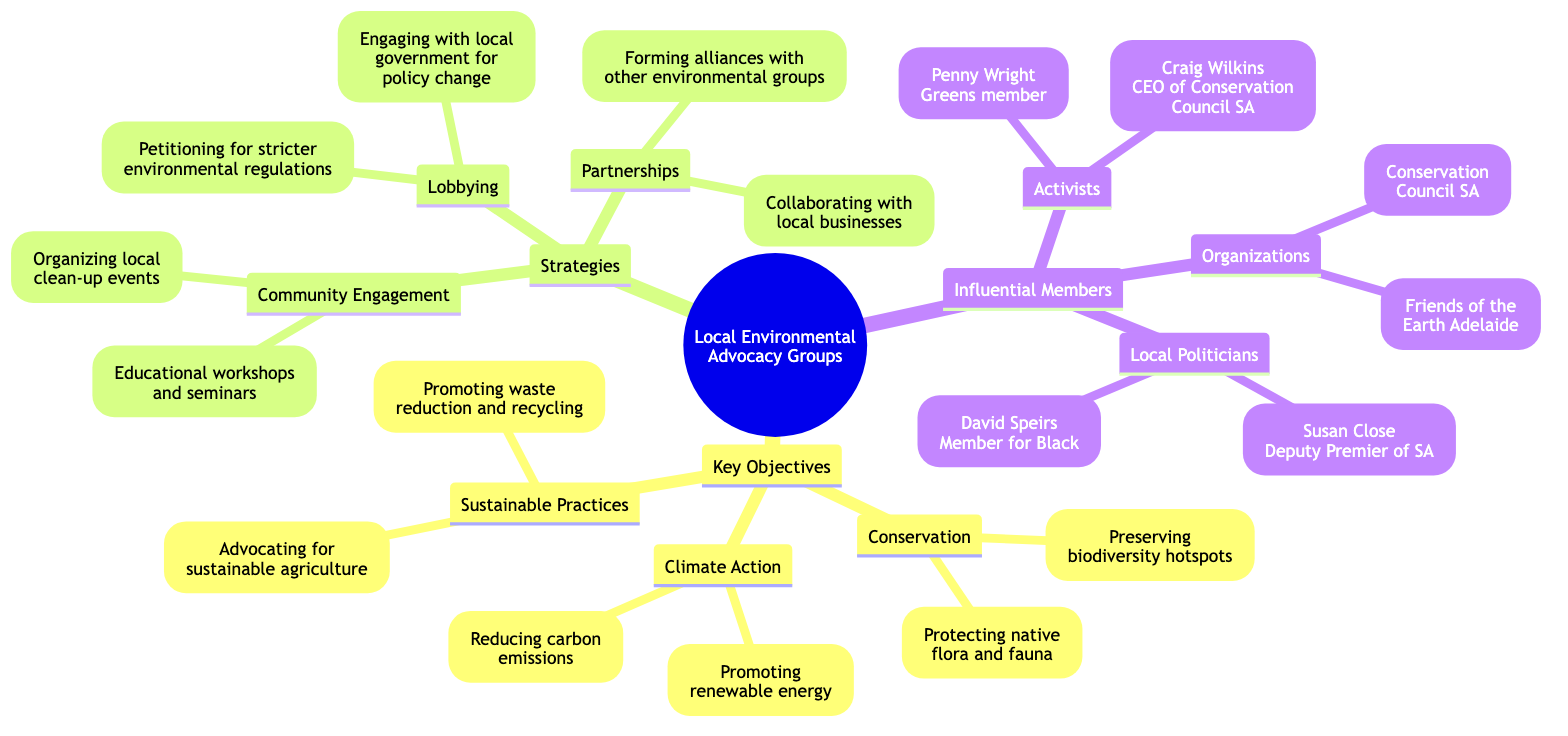What are the two key objectives under Conservation? The diagram shows two objectives listed under the "Conservation" node: "Protecting native flora and fauna" and "Preserving biodiversity hotspots". These are directly mentioned under the Conservation key objective in the mind map.
Answer: Protecting native flora and fauna, Preserving biodiversity hotspots How many strategies are listed in the diagram? The diagram has three main strategy categories: "Community Engagement," "Lobbying," and "Partnerships." Each of these counts as one strategy, leading to a total count of three strategies.
Answer: 3 Who is the Deputy Premier of South Australia mentioned in the diagram? The influential members category includes "Susan Close (Deputy Premier of South Australia)." This is directly stated in the minds map under the "Local Politicians" node.
Answer: Susan Close What type of events do advocacy groups organize under Community Engagement? The Community Engagement strategy lists two activities, one of which is "Organizing local clean-up events." This is stated in the diagram under that specific strategy branch.
Answer: Organizing local clean-up events Which activist is listed as the CEO of Conservation Council SA? The diagram identifies "Craig Wilkins" as the CEO of the Conservation Council SA under the "Activists" node. This information is obtained directly from the mind map structure.
Answer: Craig Wilkins What is a strategy used for promoting environmental policies? The diagram indicates that "Lobbying" is a strategy which involves engaging with local government for policy change and petitioning for stricter environmental regulations. Thus, it is clear that “Lobbying” is the strategy focused on policy promotion.
Answer: Lobbying Which influential organization is listed under "Organizations"? The mind map details two organizations, one being "Conservation Council SA" under the "Organizations" node. This is explicitly labeled in the structure.
Answer: Conservation Council SA How does the strategy of Partnerships support local environmental advocacy? The Partnerships strategy includes two main approaches: "Collaborating with local businesses" and "Forming alliances with other environmental groups." This indicates that the Partnerships strategy supports local advocacy through collaboration.
Answer: Collaborating with local businesses, Forming alliances with other environmental groups 